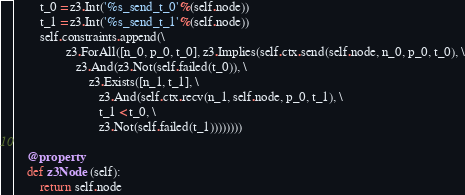Convert code to text. <code><loc_0><loc_0><loc_500><loc_500><_Python_>        t_0 = z3.Int('%s_send_t_0'%(self.node))
        t_1 = z3.Int('%s_send_t_1'%(self.node))
        self.constraints.append(\
                z3.ForAll([n_0, p_0, t_0], z3.Implies(self.ctx.send(self.node, n_0, p_0, t_0), \
                   z3.And(z3.Not(self.failed(t_0)), \
                       z3.Exists([n_1, t_1], \
                          z3.And(self.ctx.recv(n_1, self.node, p_0, t_1), \
                          t_1 < t_0, \
                          z3.Not(self.failed(t_1))))))))
                        
    @property
    def z3Node (self):
        return self.node
</code> 